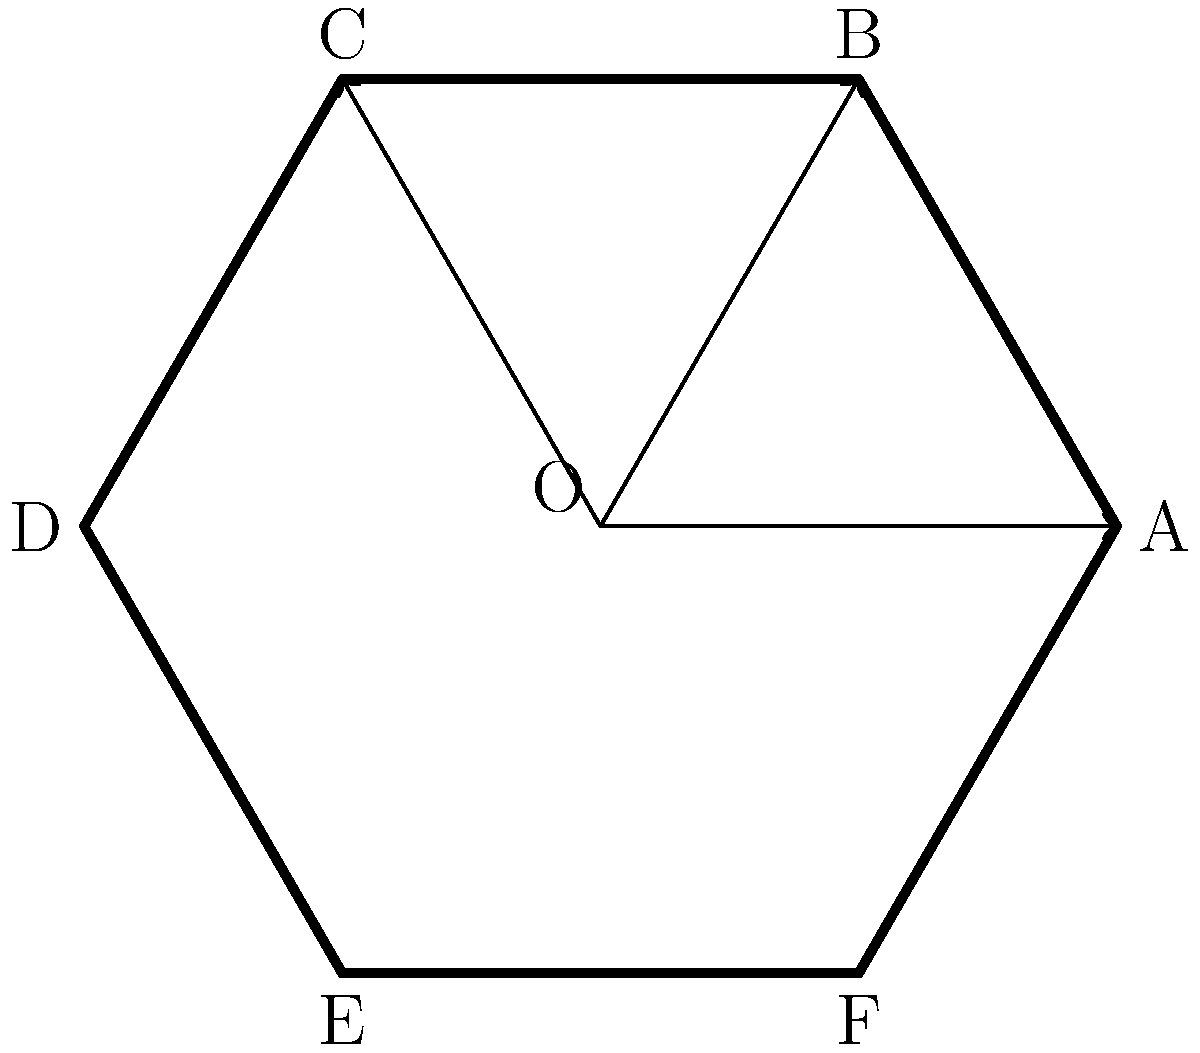Consider the firewall configuration diagram shown above, which represents a network's security structure. The diagram has rotational and reflectional symmetries. How many elements are in the symmetry group of this diagram, and what is the name of this group? To determine the symmetry group of the firewall configuration diagram, we need to analyze its rotational and reflectional symmetries:

1. Rotational symmetries:
   - The diagram has 6-fold rotational symmetry (rotations of 0°, 60°, 120°, 180°, 240°, and 300°).
   - This gives us 6 rotational symmetries.

2. Reflectional symmetries:
   - There are 6 lines of reflection (through each vertex and the midpoint of each side).
   - This gives us 6 reflectional symmetries.

3. Total number of symmetries:
   - The total number of elements in the symmetry group is the sum of rotational and reflectional symmetries.
   - 6 (rotations) + 6 (reflections) = 12 elements

4. Identifying the group:
   - A group with 12 elements that includes both rotations and reflections of a regular hexagon is known as the dihedral group of order 12, denoted as $D_6$ or $D_{12}$ (depending on the notation system used).
   - The subscript 6 in $D_6$ refers to the number of vertices or sides in the polygon, while 12 in $D_{12}$ refers to the total number of symmetries.

5. Properties of the dihedral group:
   - It is non-abelian (not all elements commute).
   - It contains both rotations and reflections.
   - It is the symmetry group of a regular polygon with n sides (in this case, n=6).

Therefore, the symmetry group of this firewall configuration diagram has 12 elements and is the dihedral group $D_6$ (or $D_{12}$).
Answer: 12 elements; Dihedral group $D_6$ (or $D_{12}$) 